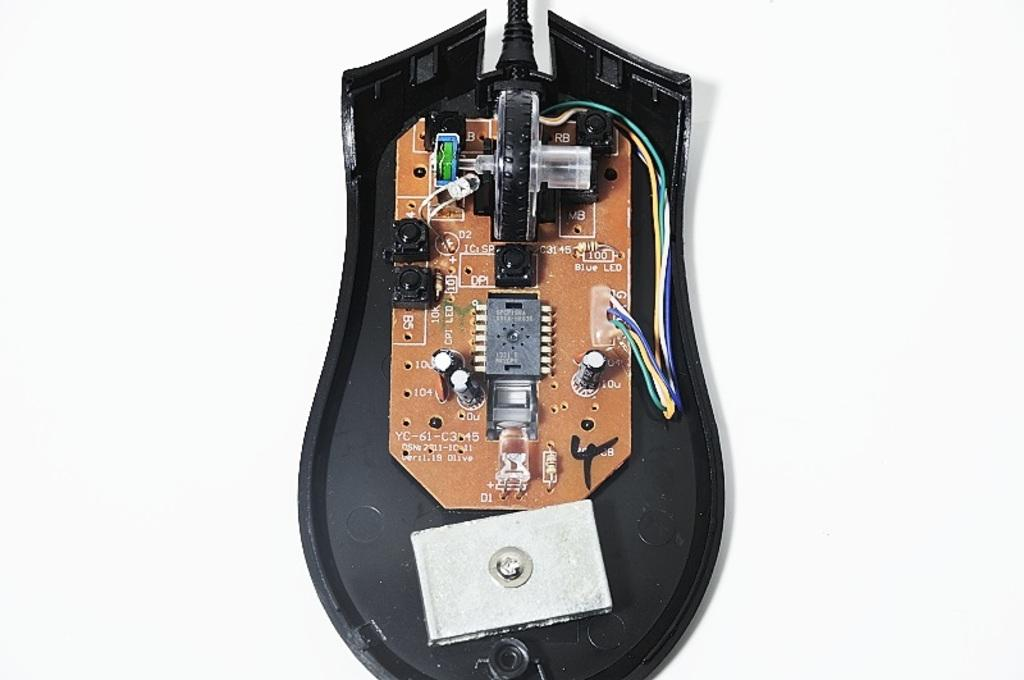What type of components can be seen in the image? There are circuits and wires in the image. What is the color of the object on which the circuits and wires are placed? The circuits and wires are on a black object. What other color is present in the image? There is a white object in the image. What color is the background of the image? The background of the image is white. How many trees can be seen in the image? There are no trees present in the image. What type of brick is used to build the structure in the image? There is no structure or brick present in the image. 